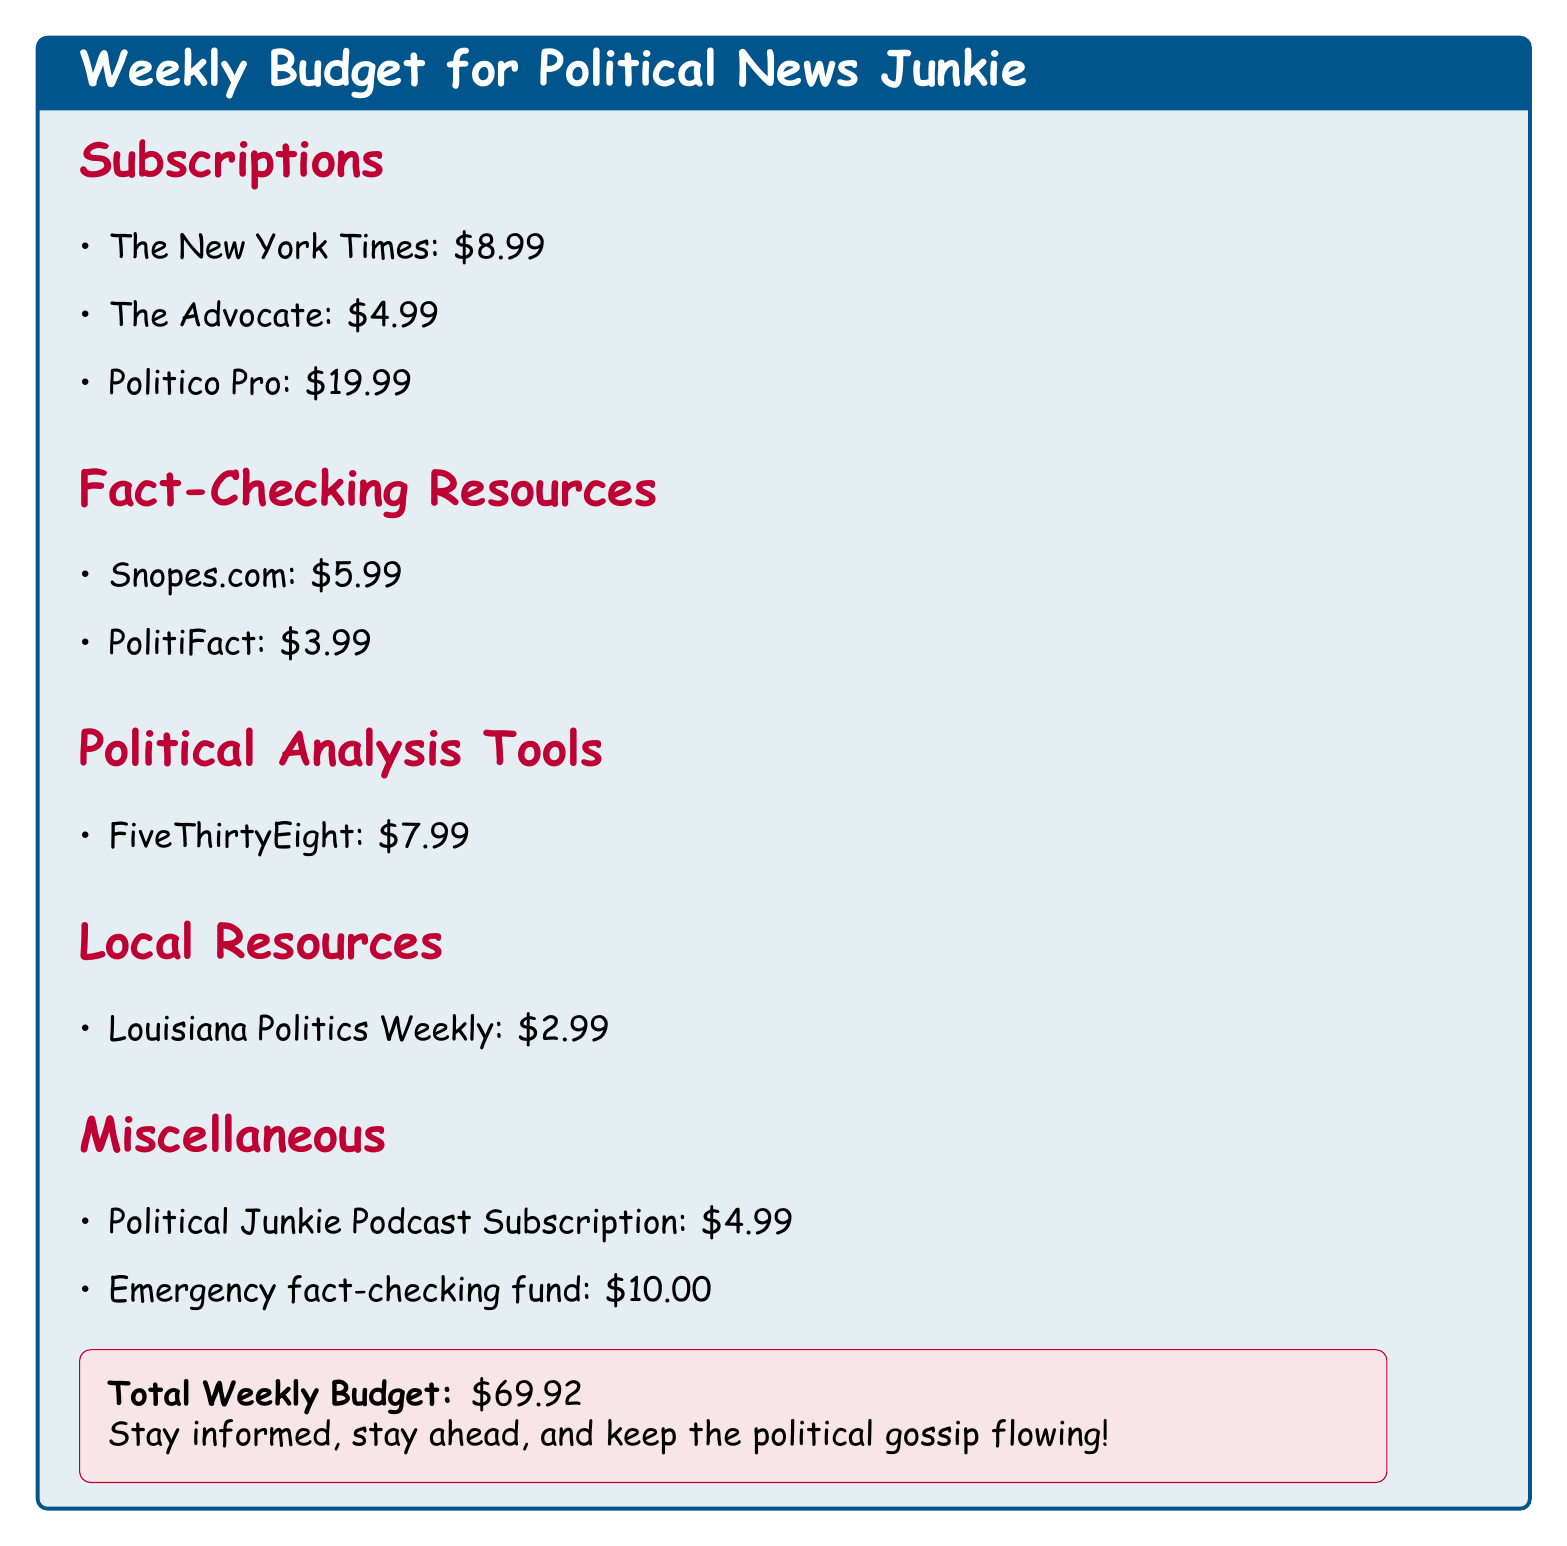What is the total weekly budget? The total weekly budget is listed in the document as the sum of all subscriptions, resources, and miscellaneous items.
Answer: $69.92 How much is the subscription to The New York Times? The document specifies the cost for The New York Times subscription, which is detailed in the Subscriptions section.
Answer: $8.99 Which fact-checking resource costs the least? The document lists various fact-checking resources along with their costs; the lowest one is found in the Fact-Checking Resources section.
Answer: PolitiFact How many local resources are listed? The document contains a Local Resources section where items are enumerated; counting them reveals the total.
Answer: 1 What is the cost of the Political Junkie Podcast Subscription? The document lists the Political Junkie Podcast Subscription under the Miscellaneous section with its price.
Answer: $4.99 What is the combined cost of Snopes.com and PolitiFact? This question requires summing the individual costs listed for both resources in the Fact-Checking Resources section of the document.
Answer: $9.98 What type of document is this? This document is related to budgeting for political news and resources, which is indicated in the title box.
Answer: Budget What is the price for Louisiana Politics Weekly? The cost is specified in the Local Resources section of the document.
Answer: $2.99 How much is allocated for the Emergency fact-checking fund? The document provides a figure in the Miscellaneous section specifically for this fund.
Answer: $10.00 